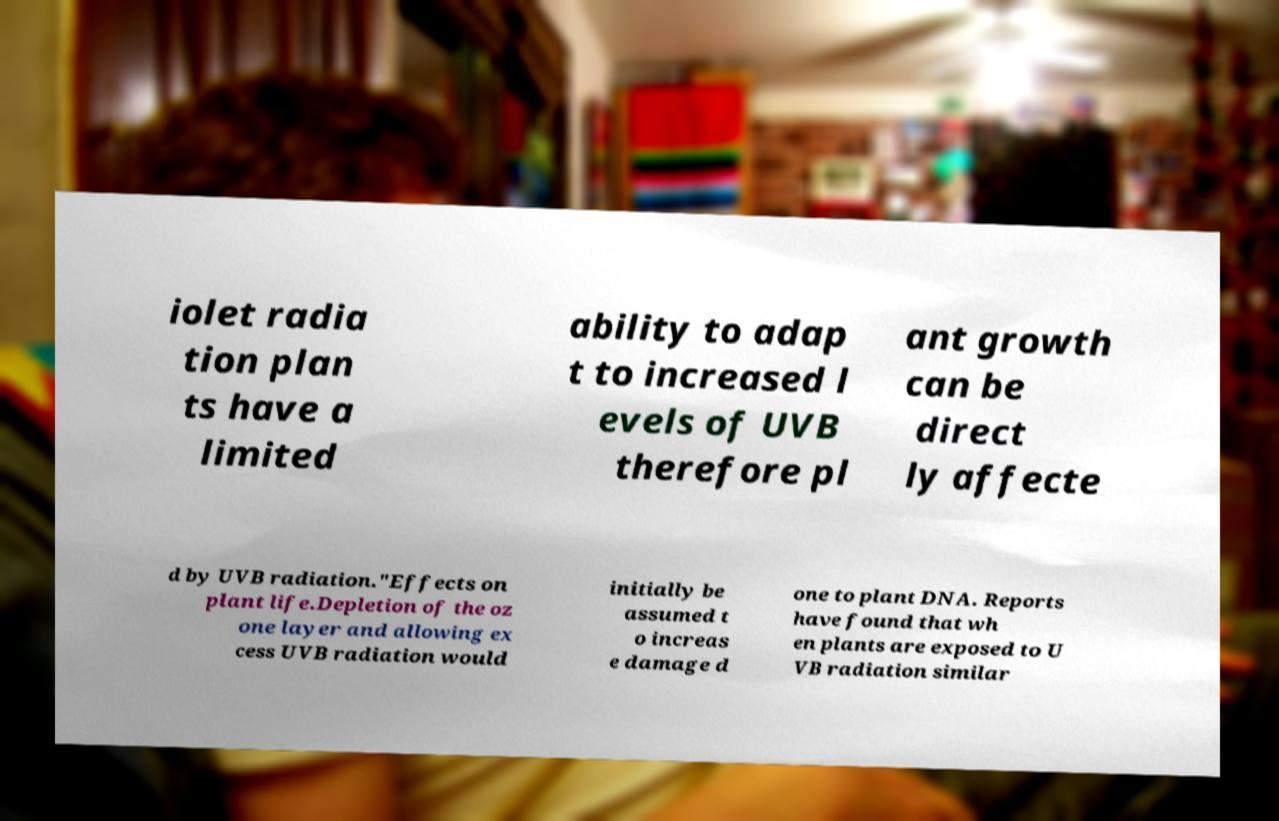Can you accurately transcribe the text from the provided image for me? iolet radia tion plan ts have a limited ability to adap t to increased l evels of UVB therefore pl ant growth can be direct ly affecte d by UVB radiation."Effects on plant life.Depletion of the oz one layer and allowing ex cess UVB radiation would initially be assumed t o increas e damage d one to plant DNA. Reports have found that wh en plants are exposed to U VB radiation similar 